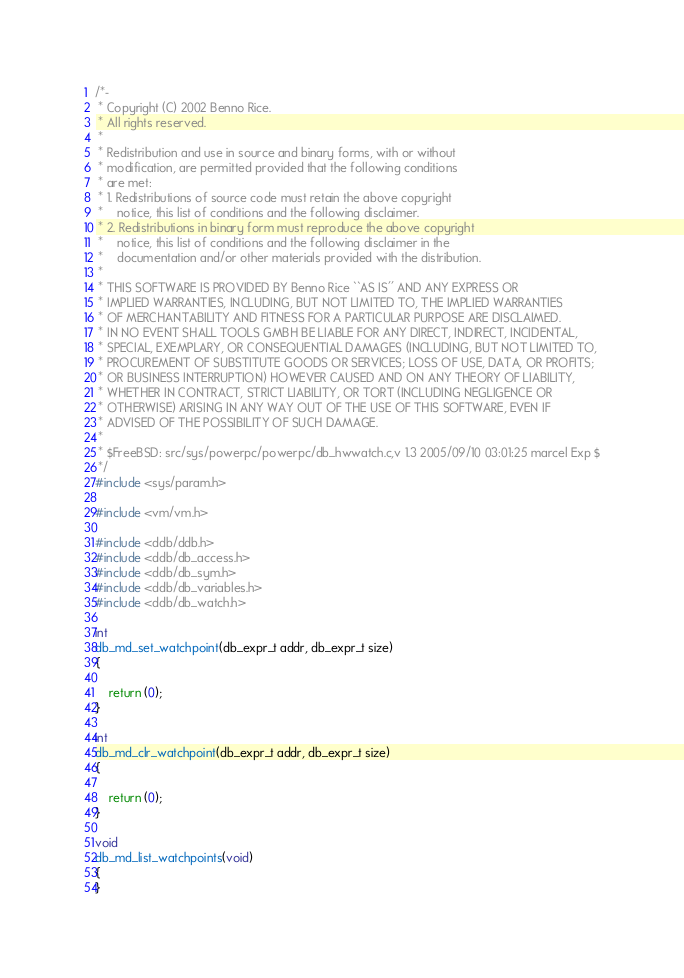<code> <loc_0><loc_0><loc_500><loc_500><_C_>/*-
 * Copyright (C) 2002 Benno Rice.
 * All rights reserved.
 *
 * Redistribution and use in source and binary forms, with or without
 * modification, are permitted provided that the following conditions
 * are met:
 * 1. Redistributions of source code must retain the above copyright
 *    notice, this list of conditions and the following disclaimer.
 * 2. Redistributions in binary form must reproduce the above copyright
 *    notice, this list of conditions and the following disclaimer in the
 *    documentation and/or other materials provided with the distribution.
 *
 * THIS SOFTWARE IS PROVIDED BY Benno Rice ``AS IS'' AND ANY EXPRESS OR
 * IMPLIED WARRANTIES, INCLUDING, BUT NOT LIMITED TO, THE IMPLIED WARRANTIES
 * OF MERCHANTABILITY AND FITNESS FOR A PARTICULAR PURPOSE ARE DISCLAIMED.
 * IN NO EVENT SHALL TOOLS GMBH BE LIABLE FOR ANY DIRECT, INDIRECT, INCIDENTAL,
 * SPECIAL, EXEMPLARY, OR CONSEQUENTIAL DAMAGES (INCLUDING, BUT NOT LIMITED TO,
 * PROCUREMENT OF SUBSTITUTE GOODS OR SERVICES; LOSS OF USE, DATA, OR PROFITS;
 * OR BUSINESS INTERRUPTION) HOWEVER CAUSED AND ON ANY THEORY OF LIABILITY,
 * WHETHER IN CONTRACT, STRICT LIABILITY, OR TORT (INCLUDING NEGLIGENCE OR
 * OTHERWISE) ARISING IN ANY WAY OUT OF THE USE OF THIS SOFTWARE, EVEN IF
 * ADVISED OF THE POSSIBILITY OF SUCH DAMAGE.
 *
 * $FreeBSD: src/sys/powerpc/powerpc/db_hwwatch.c,v 1.3 2005/09/10 03:01:25 marcel Exp $
 */
#include <sys/param.h>

#include <vm/vm.h>

#include <ddb/ddb.h>
#include <ddb/db_access.h>
#include <ddb/db_sym.h>
#include <ddb/db_variables.h>
#include <ddb/db_watch.h>

int
db_md_set_watchpoint(db_expr_t addr, db_expr_t size)
{

	return (0);
}

int
db_md_clr_watchpoint(db_expr_t addr, db_expr_t size)
{

	return (0);
}

void
db_md_list_watchpoints(void)
{
}
</code> 